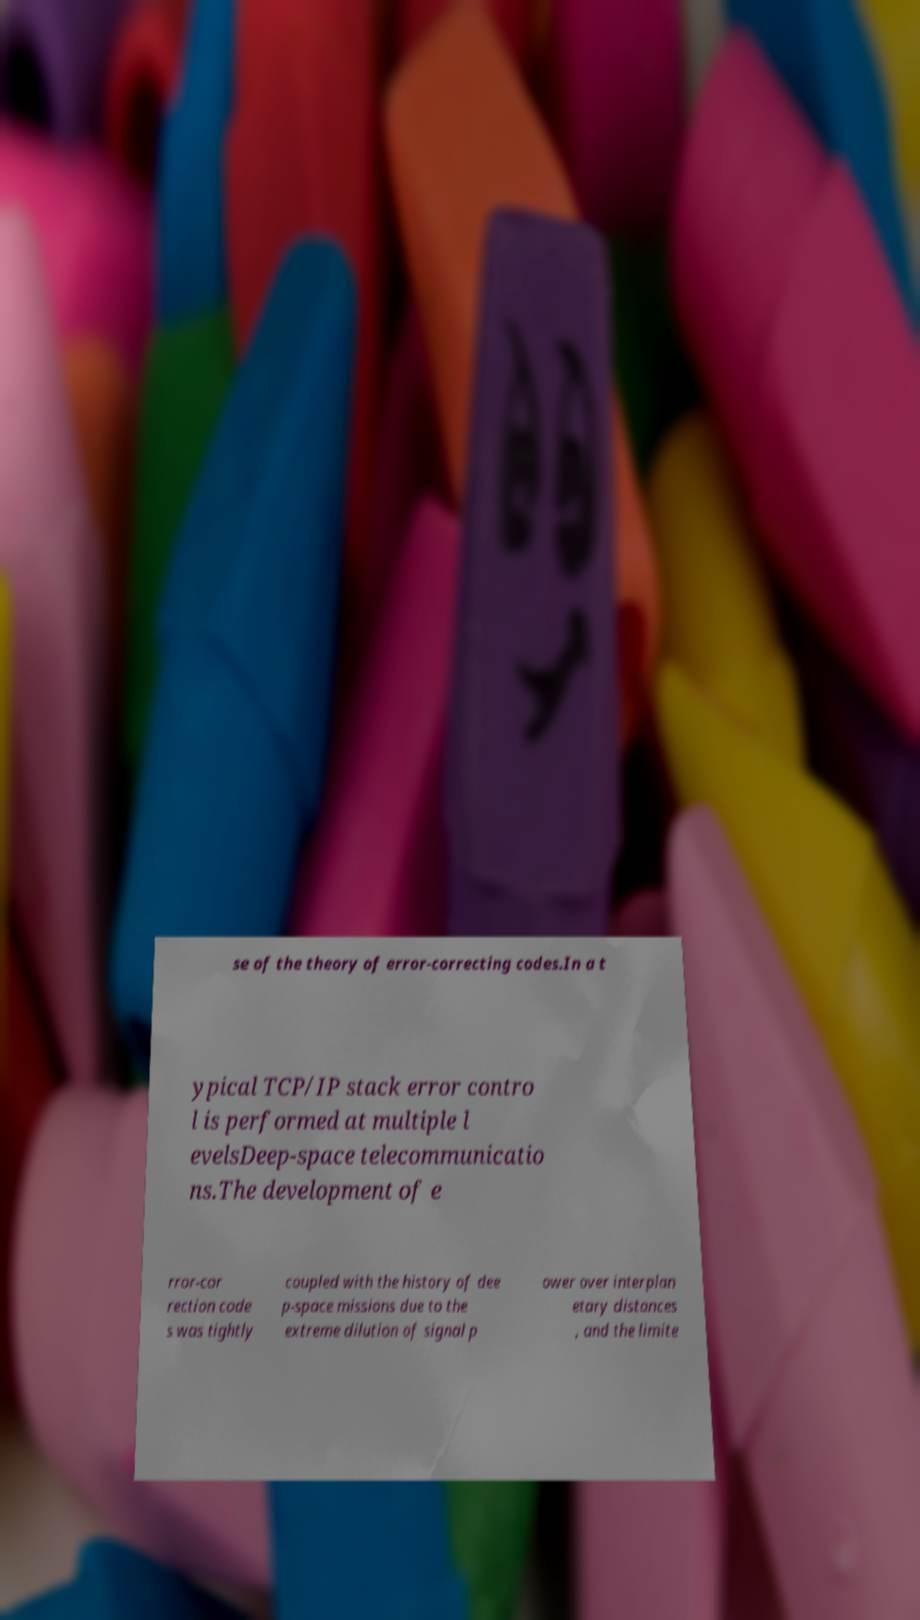Could you assist in decoding the text presented in this image and type it out clearly? se of the theory of error-correcting codes.In a t ypical TCP/IP stack error contro l is performed at multiple l evelsDeep-space telecommunicatio ns.The development of e rror-cor rection code s was tightly coupled with the history of dee p-space missions due to the extreme dilution of signal p ower over interplan etary distances , and the limite 